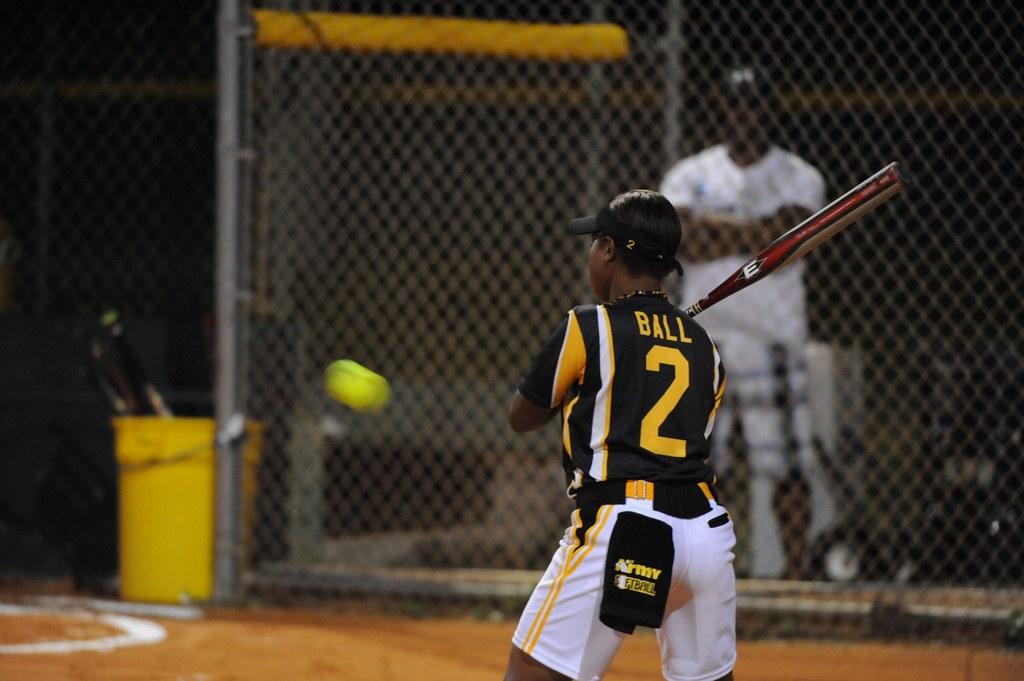What is the players name?
Your answer should be compact. Ball. 